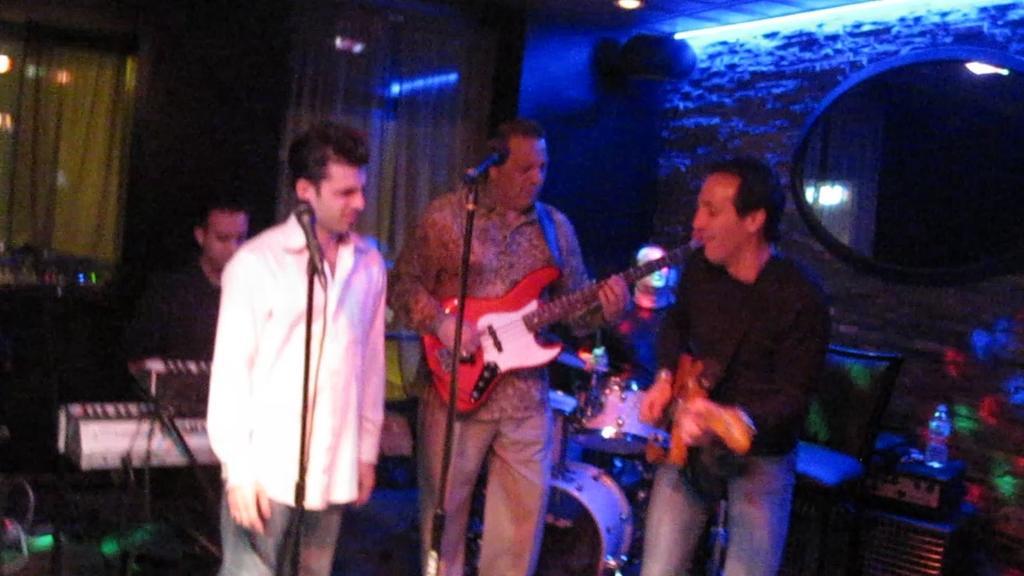Describe this image in one or two sentences. In this image there are four person playing a musical instrument. There is a mic and a stand. 